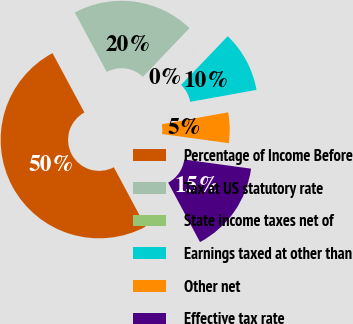Convert chart. <chart><loc_0><loc_0><loc_500><loc_500><pie_chart><fcel>Percentage of Income Before<fcel>Tax at US statutory rate<fcel>State income taxes net of<fcel>Earnings taxed at other than<fcel>Other net<fcel>Effective tax rate<nl><fcel>49.97%<fcel>20.0%<fcel>0.01%<fcel>10.01%<fcel>5.01%<fcel>15.0%<nl></chart> 